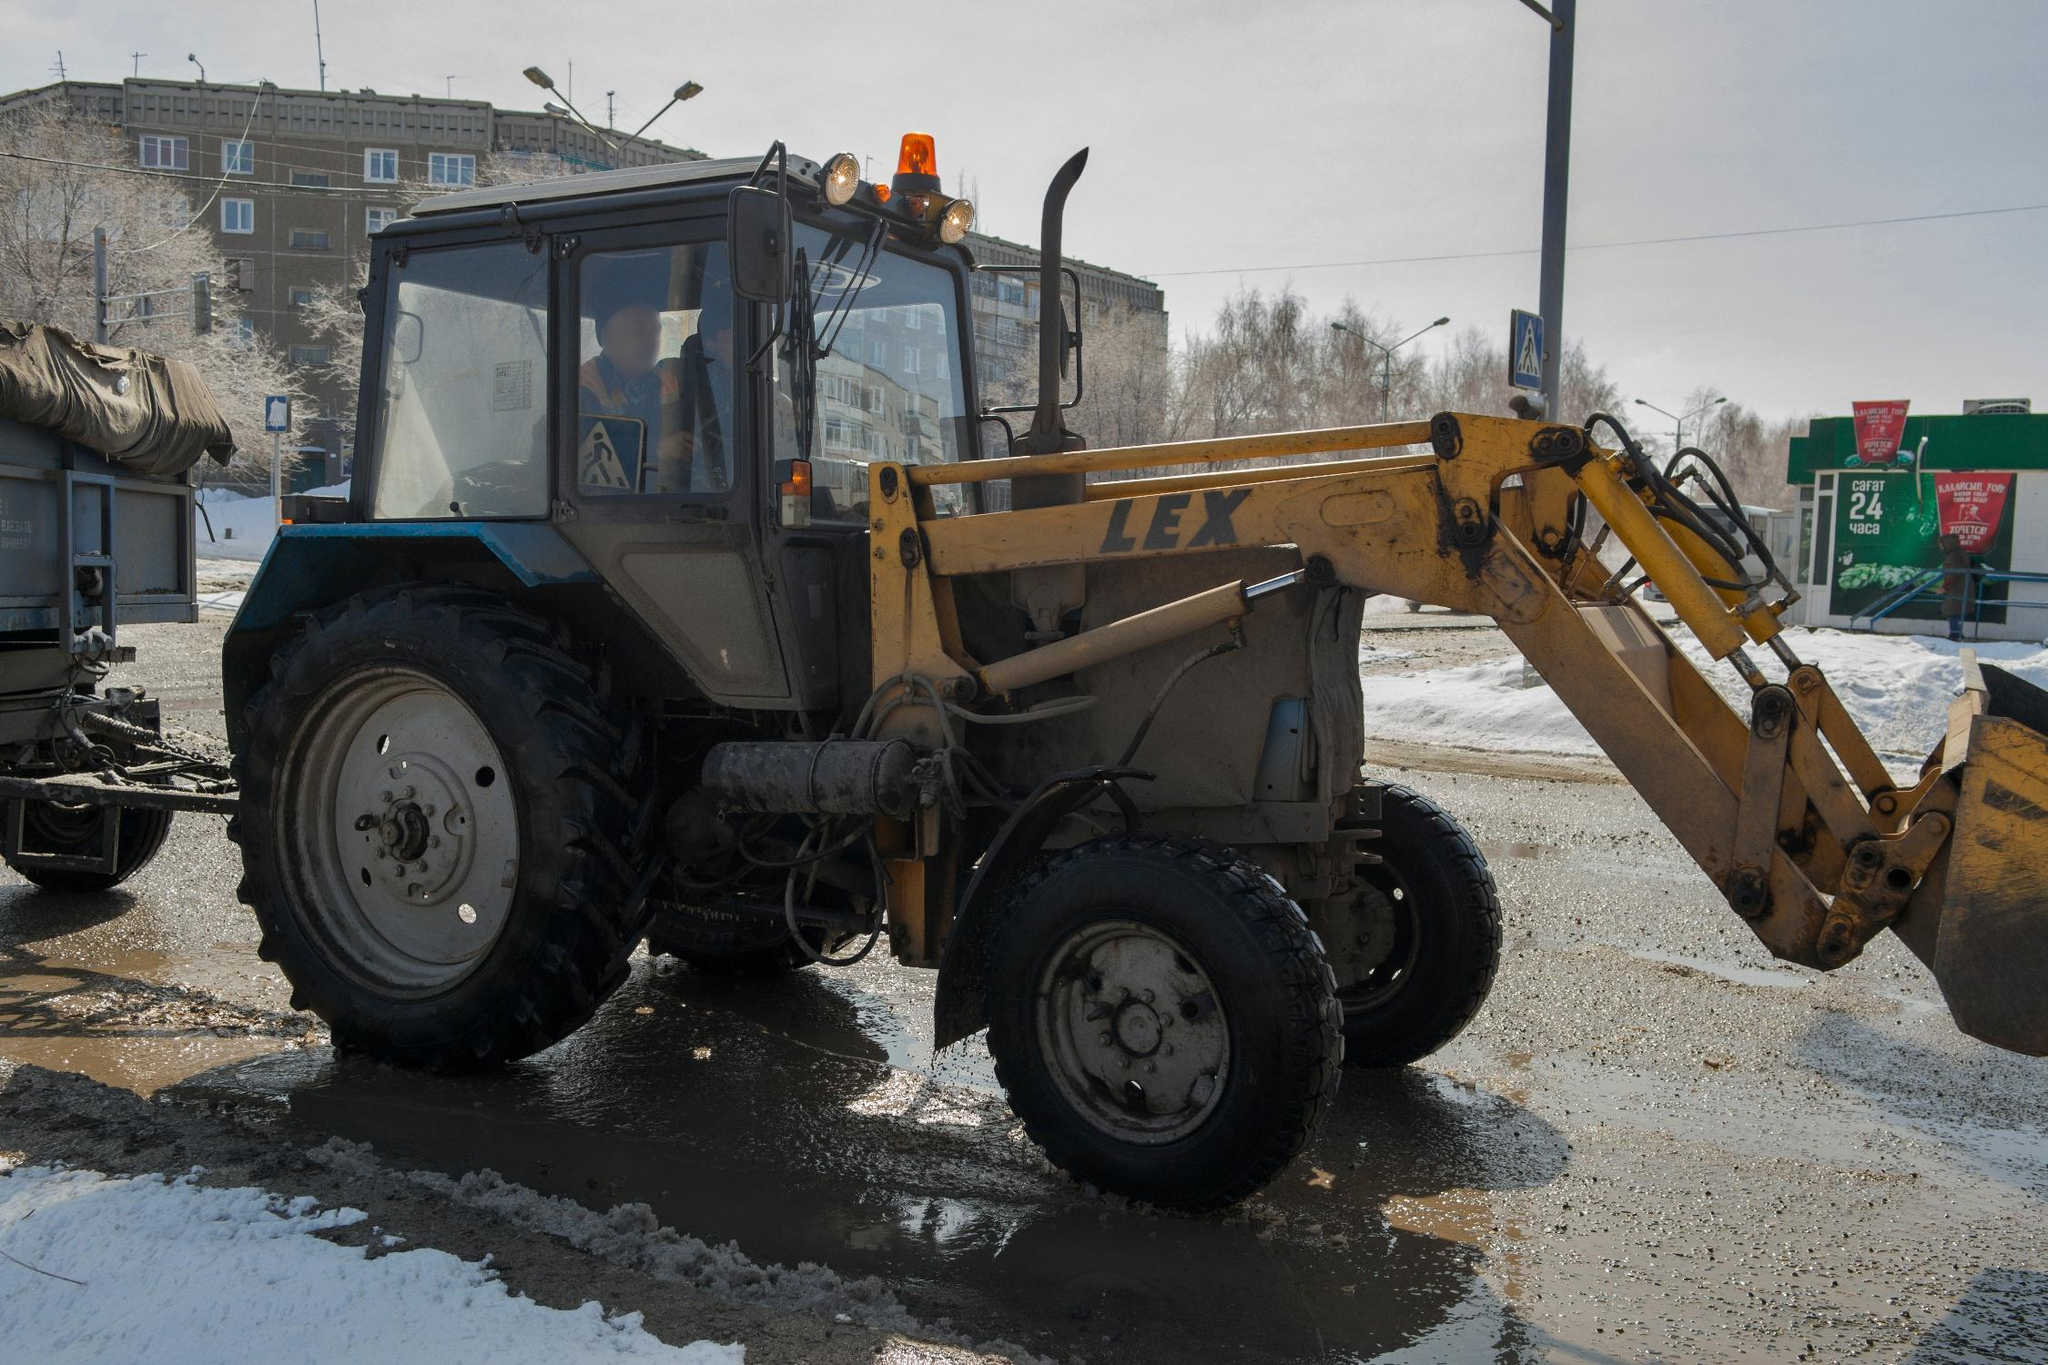Can you elaborate on the elements of the picture provided? The image captures a yellow and black tractor, notably equipped with a front loader and marked with a 'LEX' logo, parked on a snowy and slushy street. This sturdy vehicle faces left, and its front loader is down, touching the wet ground, suggesting recent or impending use for snow clearing or material handling. 

In the driver's seat, a figure is visible, indicating active operation. The street itself shows signs of traffic, indicated by the wet patches and scattered snow, intersecting daily life and urban duties. Behind the tractor, a utilitarian landscape unfolds with a street lamp and buildings that look residential and perhaps commercial, hinting at the mixed-use nature of the area. A green billboard in the background might be offering local advertisments, adding a layer of community engagement to the scene. The overall setting reflects a bustling urban environment adapting to winter conditions, with machinery like this tractor playing a critical role in routine maintenance and functionality. 